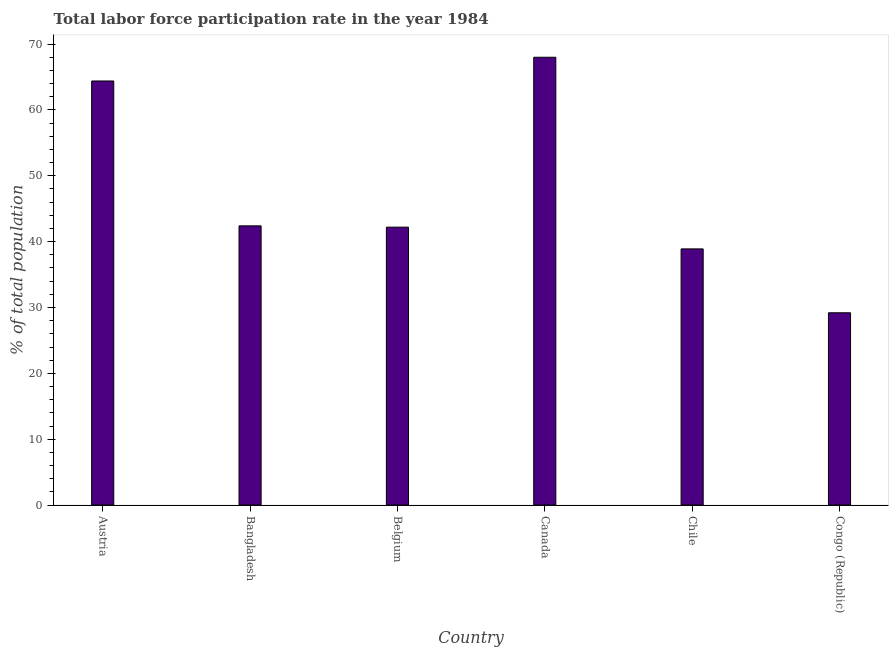Does the graph contain any zero values?
Offer a terse response. No. What is the title of the graph?
Offer a terse response. Total labor force participation rate in the year 1984. What is the label or title of the X-axis?
Make the answer very short. Country. What is the label or title of the Y-axis?
Keep it short and to the point. % of total population. What is the total labor force participation rate in Bangladesh?
Provide a succinct answer. 42.4. Across all countries, what is the minimum total labor force participation rate?
Give a very brief answer. 29.2. In which country was the total labor force participation rate minimum?
Offer a very short reply. Congo (Republic). What is the sum of the total labor force participation rate?
Keep it short and to the point. 285.1. What is the difference between the total labor force participation rate in Austria and Belgium?
Make the answer very short. 22.2. What is the average total labor force participation rate per country?
Your answer should be very brief. 47.52. What is the median total labor force participation rate?
Make the answer very short. 42.3. In how many countries, is the total labor force participation rate greater than 66 %?
Provide a succinct answer. 1. What is the ratio of the total labor force participation rate in Canada to that in Congo (Republic)?
Keep it short and to the point. 2.33. Is the total labor force participation rate in Austria less than that in Canada?
Give a very brief answer. Yes. Is the difference between the total labor force participation rate in Bangladesh and Congo (Republic) greater than the difference between any two countries?
Your response must be concise. No. What is the difference between the highest and the second highest total labor force participation rate?
Your answer should be compact. 3.6. Is the sum of the total labor force participation rate in Belgium and Chile greater than the maximum total labor force participation rate across all countries?
Your answer should be compact. Yes. What is the difference between the highest and the lowest total labor force participation rate?
Keep it short and to the point. 38.8. How many bars are there?
Provide a short and direct response. 6. Are all the bars in the graph horizontal?
Keep it short and to the point. No. What is the difference between two consecutive major ticks on the Y-axis?
Your response must be concise. 10. Are the values on the major ticks of Y-axis written in scientific E-notation?
Your answer should be compact. No. What is the % of total population of Austria?
Your response must be concise. 64.4. What is the % of total population in Bangladesh?
Offer a terse response. 42.4. What is the % of total population of Belgium?
Make the answer very short. 42.2. What is the % of total population of Chile?
Give a very brief answer. 38.9. What is the % of total population in Congo (Republic)?
Ensure brevity in your answer.  29.2. What is the difference between the % of total population in Austria and Bangladesh?
Provide a short and direct response. 22. What is the difference between the % of total population in Austria and Congo (Republic)?
Your answer should be compact. 35.2. What is the difference between the % of total population in Bangladesh and Belgium?
Provide a succinct answer. 0.2. What is the difference between the % of total population in Bangladesh and Canada?
Give a very brief answer. -25.6. What is the difference between the % of total population in Bangladesh and Chile?
Keep it short and to the point. 3.5. What is the difference between the % of total population in Bangladesh and Congo (Republic)?
Offer a terse response. 13.2. What is the difference between the % of total population in Belgium and Canada?
Your response must be concise. -25.8. What is the difference between the % of total population in Canada and Chile?
Offer a very short reply. 29.1. What is the difference between the % of total population in Canada and Congo (Republic)?
Your answer should be compact. 38.8. What is the difference between the % of total population in Chile and Congo (Republic)?
Your response must be concise. 9.7. What is the ratio of the % of total population in Austria to that in Bangladesh?
Give a very brief answer. 1.52. What is the ratio of the % of total population in Austria to that in Belgium?
Your answer should be very brief. 1.53. What is the ratio of the % of total population in Austria to that in Canada?
Provide a short and direct response. 0.95. What is the ratio of the % of total population in Austria to that in Chile?
Your answer should be very brief. 1.66. What is the ratio of the % of total population in Austria to that in Congo (Republic)?
Ensure brevity in your answer.  2.21. What is the ratio of the % of total population in Bangladesh to that in Canada?
Your answer should be compact. 0.62. What is the ratio of the % of total population in Bangladesh to that in Chile?
Your response must be concise. 1.09. What is the ratio of the % of total population in Bangladesh to that in Congo (Republic)?
Your answer should be very brief. 1.45. What is the ratio of the % of total population in Belgium to that in Canada?
Provide a succinct answer. 0.62. What is the ratio of the % of total population in Belgium to that in Chile?
Provide a succinct answer. 1.08. What is the ratio of the % of total population in Belgium to that in Congo (Republic)?
Offer a very short reply. 1.45. What is the ratio of the % of total population in Canada to that in Chile?
Provide a succinct answer. 1.75. What is the ratio of the % of total population in Canada to that in Congo (Republic)?
Ensure brevity in your answer.  2.33. What is the ratio of the % of total population in Chile to that in Congo (Republic)?
Provide a succinct answer. 1.33. 